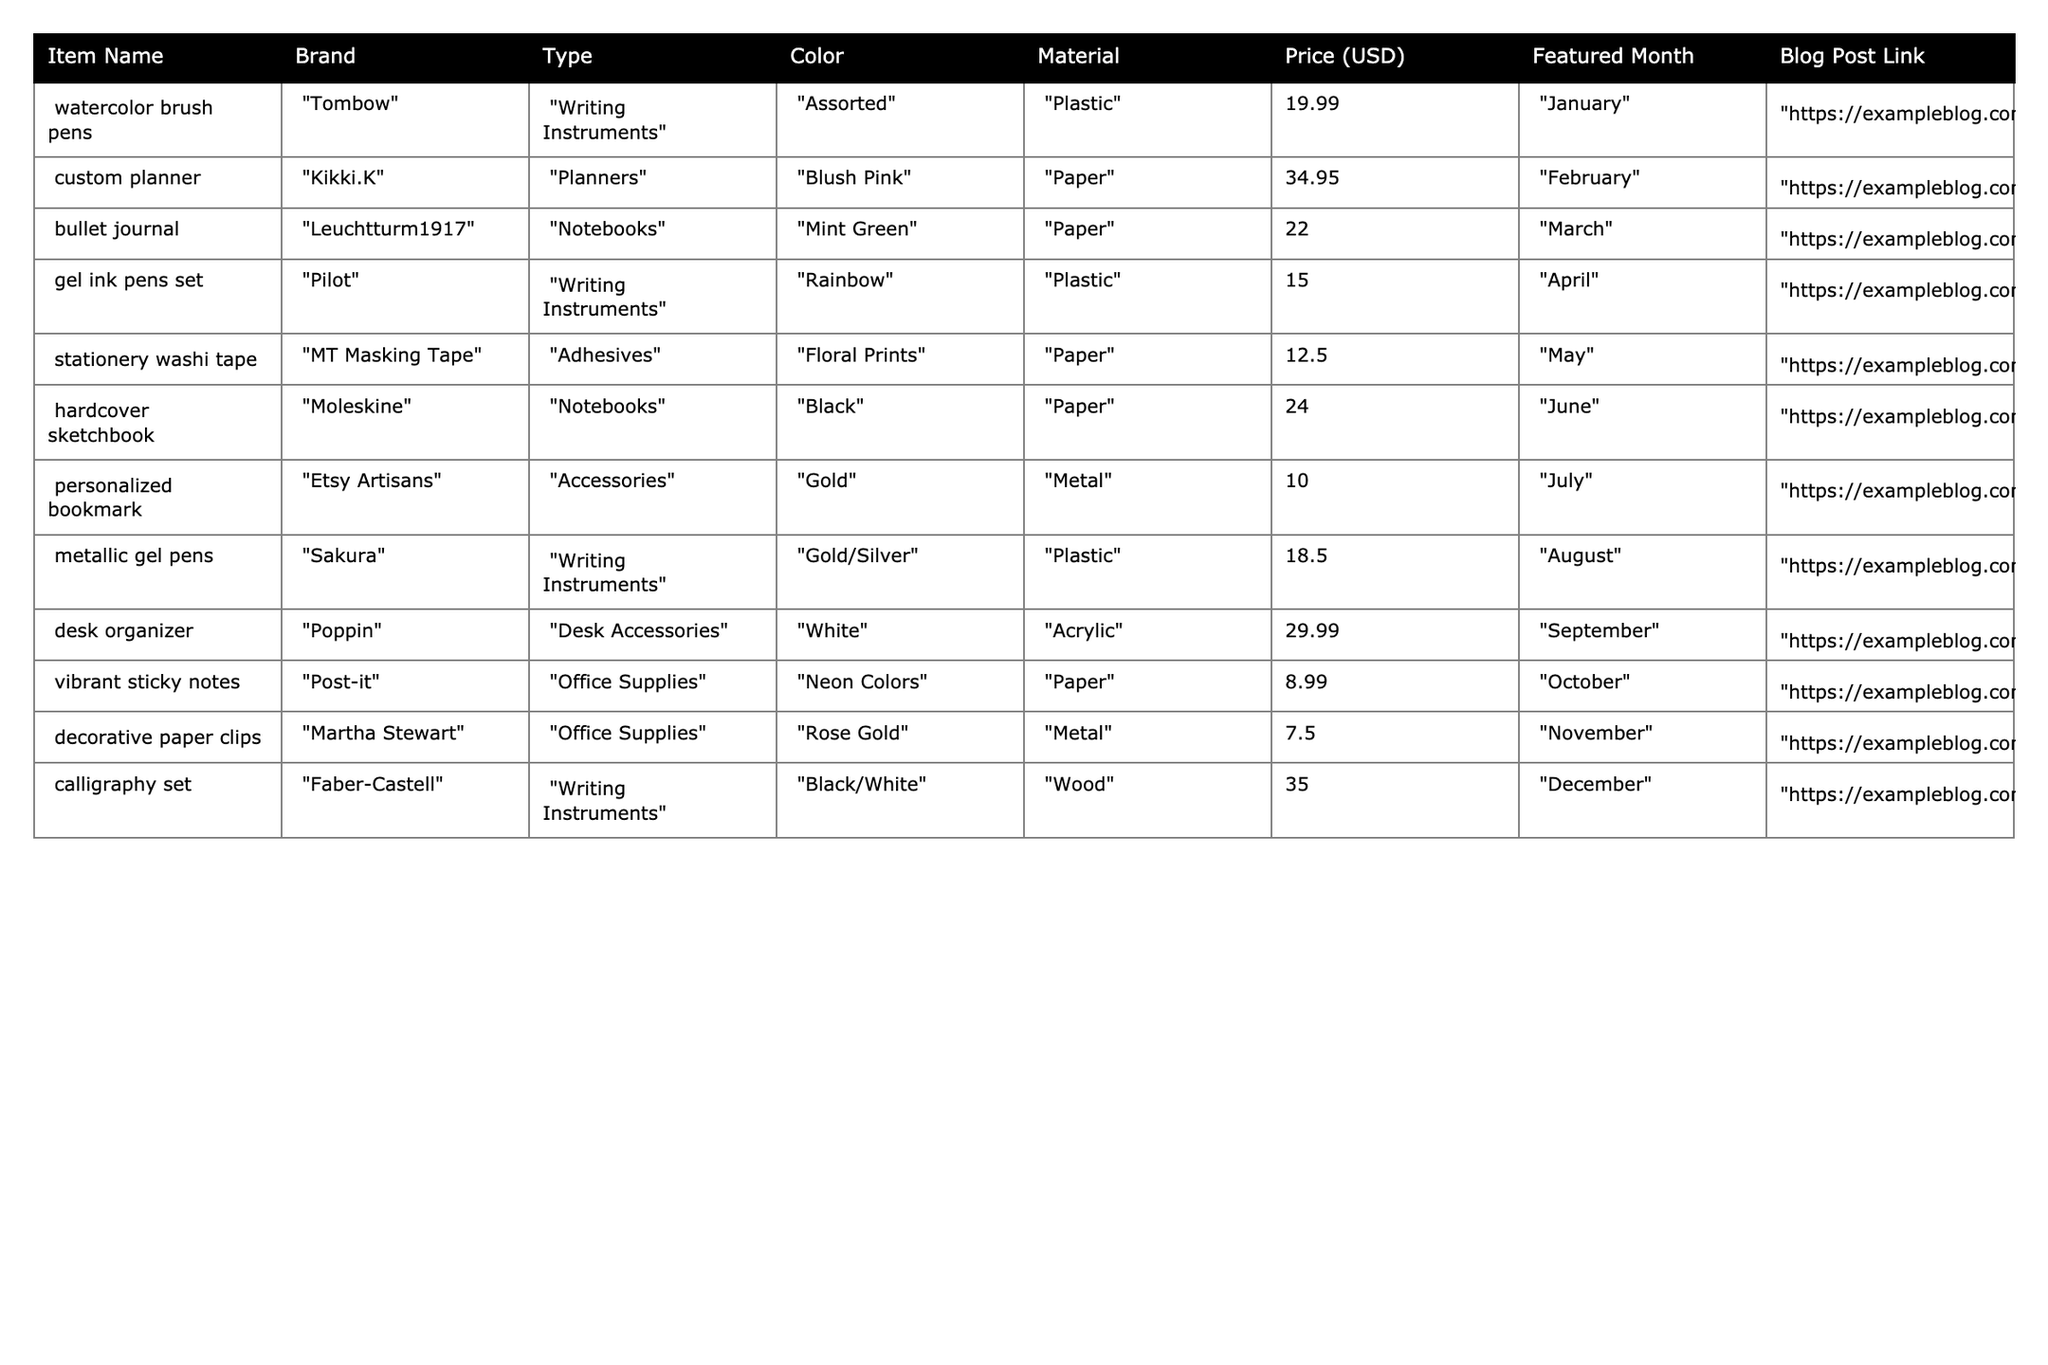What item has the highest price? The prices are listed in the table, and the maximum price found is $35.00 for the calligraphy set from Faber-Castell.
Answer: $35.00 Which brand offers the lowest-priced item? By reviewing the prices in the table, I can see that the decorative paper clips from Martha Stewart are priced at $7.50, making it the lowest-priced item.
Answer: Martha Stewart How many different types of stationery items are featured in the table? The types listed are Writing Instruments, Planners, Notebooks, Adhesives, Desk Accessories, Office Supplies, and Accessories. Counting these gives a total of 7 different types.
Answer: 7 What is the average price of all stationery items featured? Adding all the prices gives: 19.99 + 34.95 + 22 + 15 + 12.50 + 24 + 10 + 18.50 + 29.99 + 8.99 + 7.50 + 35 =  264.42. There are 12 items, so the average price is 264.42 / 12 = 22.0366667, rounded to two decimal places is $22.04.
Answer: $22.04 Did any item feature in the month of October? The table indicates that there is a vibrant sticky notes featured in October.
Answer: Yes Which item is the only one made of wood? The calligraphy set from Faber-Castell is the only item made of wood according to the table.
Answer: Calligraphy set What's the total number of Writing Instruments in the inventory? There are four items classified as Writing Instruments: watercolor brush pens, gel ink pens set, metallic gel pens, and calligraphy set, totaling four items.
Answer: 4 Which month featured the lowest-priced item, and what was it? The lowest-priced item is the decorative paper clips featured in November, priced at $7.50 according to the table.
Answer: November, $7.50 How many items have a featured color of 'Black'? The only item with 'Black' as a featured color is the hardcover sketchbook.
Answer: 1 What percentage of the items are Planners? There is one planner out of 12 total items in the table. To find the percentage: (1/12) * 100 = 8.33%.
Answer: 8.33% 